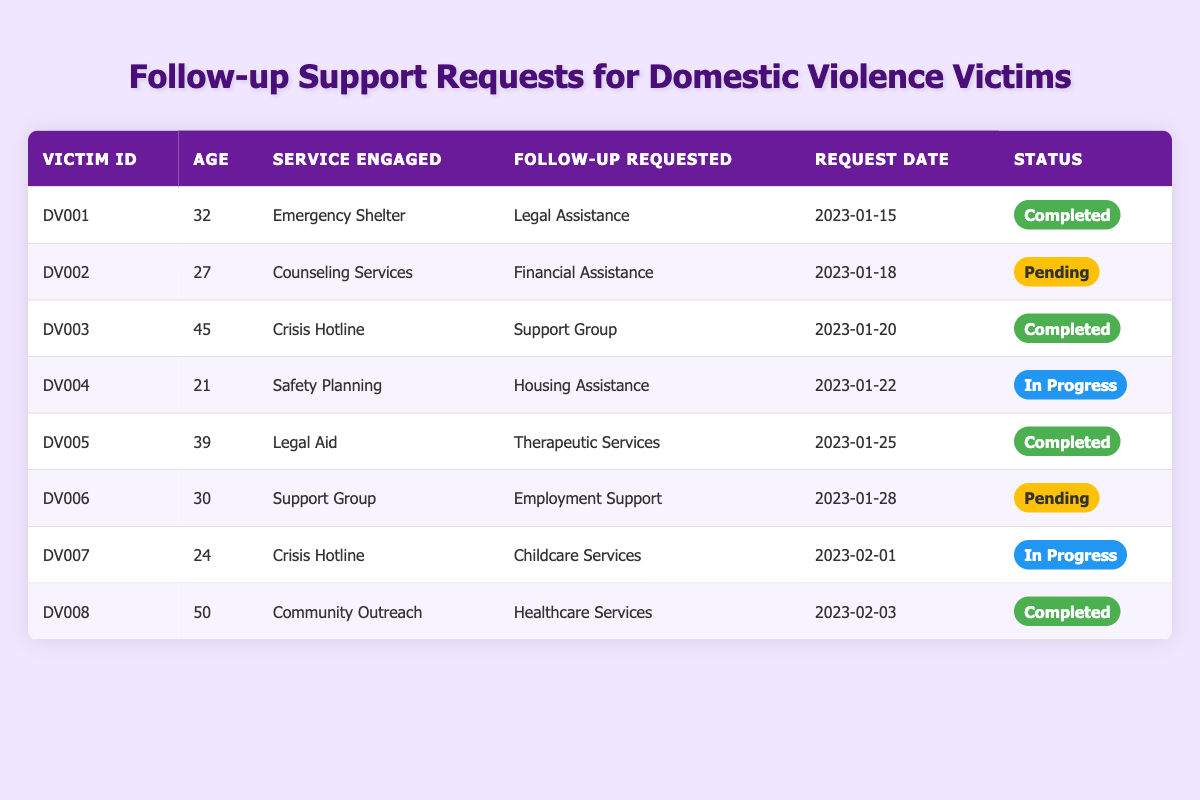What follow-up support was requested by Victim ID DV004? Victim ID DV004 requested "Housing Assistance" as a follow-up support after engaging with "Safety Planning" services. This information is found directly in the table under the respective columns for Victim ID, follow-up requested, and service engaged.
Answer: Housing Assistance How many follow-up requests have been marked as completed? In the table, there are three entries where the status is "Completed". These entries correspond to Victim IDs DV001, DV003, DV005, and DV008. By simply counting these rows, we find that there are four completed requests.
Answer: 4 What is the average age of domestic violence victims who have requested "Legal Assistance" as follow-up support? From the table, only Victim ID DV001 has requested "Legal Assistance" and that victim is 32 years old. Since there is just one request, the average age is simply the age of this victim.
Answer: 32 Which service engaged by Victim ID DV006 is associated with a "Pending" follow-up request? Looking at Victim ID DV006 in the table, the service engaged is "Support Group", and it is noteworthy that the follow-up requested is "Employment Support," which is currently labeled as "Pending". This corresponds directly to the relevant columns in the table.
Answer: Support Group Are there any victims aged 30 or older who have requested "Healthcare Services"? In the table, the only request for "Healthcare Services" was made by Victim ID DV008, who is 50 years old. Thus, the condition of being aged 30 or older is satisfied since Victim DV008 meets this criterion, confirming that the statement is true.
Answer: Yes How many victims requested support that is currently in progress? The table lists two entries with the status "In Progress," corresponding to Victim IDs DV004 and DV007. By identifying these two rows, we find that there are a total of two victims with "In Progress" requests.
Answer: 2 What follow-up request was made by the youngest victim? Victim ID DV004 is the youngest at 21 years old, and they requested "Housing Assistance". To get this information, we identify the victim's age and find the corresponding follow-up request in the same row.
Answer: Housing Assistance Which follow-up service request has the most recent request date? The most recent request date in the table is "2023-02-03" for Victim ID DV008, who requested "Healthcare Services". We can find this by looking at the dates listed in the request date column.
Answer: Healthcare Services 